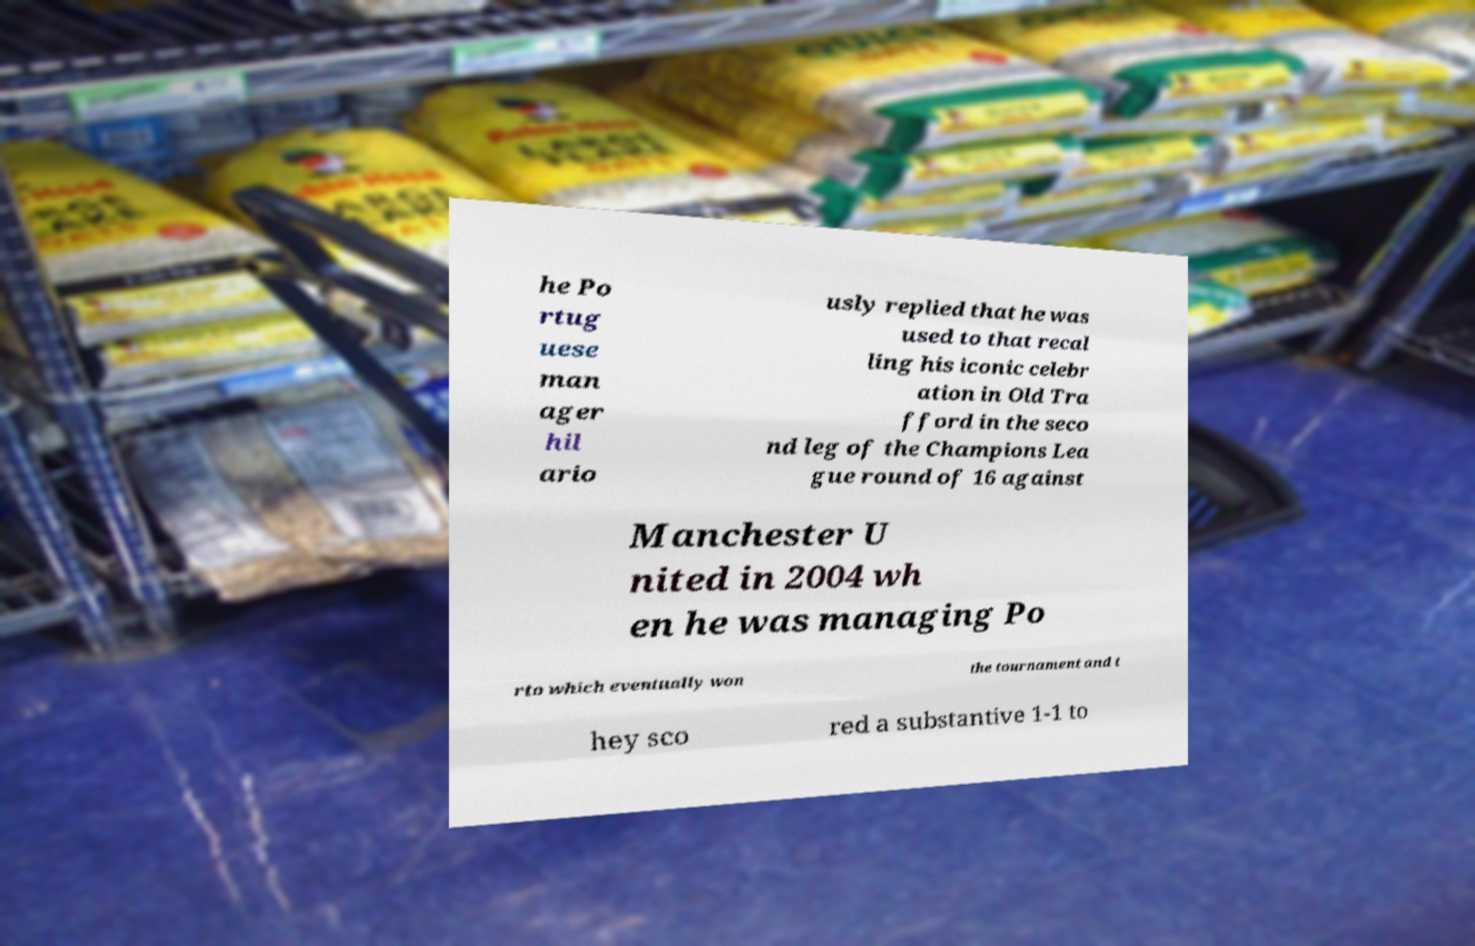There's text embedded in this image that I need extracted. Can you transcribe it verbatim? he Po rtug uese man ager hil ario usly replied that he was used to that recal ling his iconic celebr ation in Old Tra fford in the seco nd leg of the Champions Lea gue round of 16 against Manchester U nited in 2004 wh en he was managing Po rto which eventually won the tournament and t hey sco red a substantive 1-1 to 